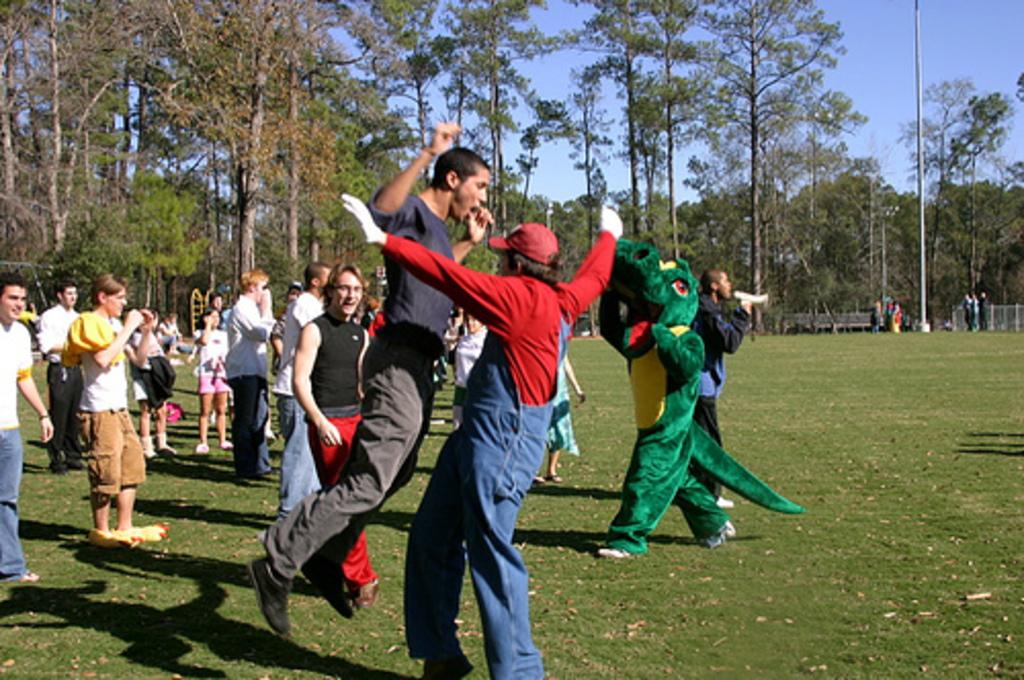Who or what can be seen in the image? There are people in the image. What type of natural environment is visible in the image? There is grass visible in the image. Can you describe the background of the image? There are people, trees, a fence, and the sky visible in the background of the image. What type of needle is being used for arithmetic in the image? There is no needle or arithmetic activity present in the image. What type of steel is visible in the image? There is no steel visible in the image. 